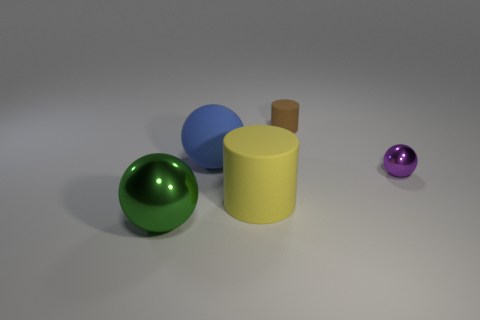Is the shape of the metal object that is to the right of the blue matte sphere the same as  the green thing?
Provide a succinct answer. Yes. How many things are small shiny spheres or large metal cubes?
Provide a short and direct response. 1. Is the material of the large sphere that is right of the big green thing the same as the small ball?
Give a very brief answer. No. What size is the blue thing?
Offer a very short reply. Large. What number of spheres are either big yellow metallic things or brown objects?
Make the answer very short. 0. Are there an equal number of cylinders behind the yellow matte thing and small purple objects that are behind the matte sphere?
Your answer should be compact. No. The yellow object that is the same shape as the brown rubber object is what size?
Ensure brevity in your answer.  Large. There is a object that is behind the yellow object and to the left of the brown rubber object; what size is it?
Give a very brief answer. Large. There is a green thing; are there any green metal things left of it?
Your response must be concise. No. How many things are shiny objects in front of the big yellow rubber object or tiny red cylinders?
Your answer should be compact. 1. 